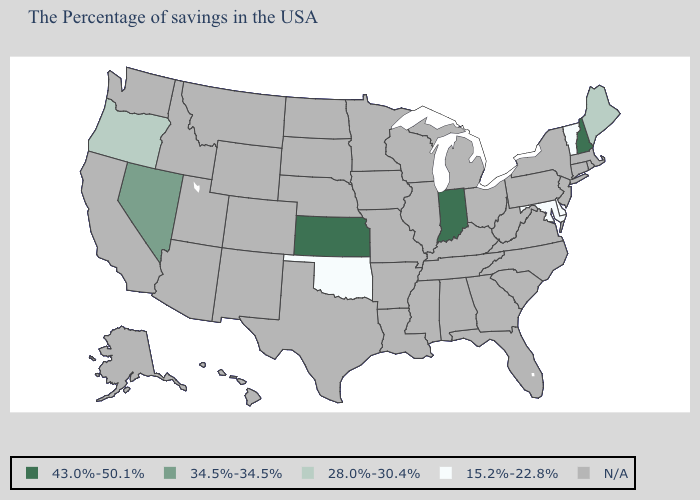Does the map have missing data?
Answer briefly. Yes. Name the states that have a value in the range 43.0%-50.1%?
Answer briefly. New Hampshire, Indiana, Kansas. What is the value of Vermont?
Quick response, please. 15.2%-22.8%. Among the states that border Idaho , does Nevada have the highest value?
Be succinct. Yes. Name the states that have a value in the range N/A?
Keep it brief. Massachusetts, Rhode Island, Connecticut, New York, New Jersey, Pennsylvania, Virginia, North Carolina, South Carolina, West Virginia, Ohio, Florida, Georgia, Michigan, Kentucky, Alabama, Tennessee, Wisconsin, Illinois, Mississippi, Louisiana, Missouri, Arkansas, Minnesota, Iowa, Nebraska, Texas, South Dakota, North Dakota, Wyoming, Colorado, New Mexico, Utah, Montana, Arizona, Idaho, California, Washington, Alaska, Hawaii. What is the value of Indiana?
Write a very short answer. 43.0%-50.1%. Which states have the lowest value in the West?
Be succinct. Oregon. What is the highest value in the West ?
Quick response, please. 34.5%-34.5%. What is the value of West Virginia?
Concise answer only. N/A. Name the states that have a value in the range N/A?
Be succinct. Massachusetts, Rhode Island, Connecticut, New York, New Jersey, Pennsylvania, Virginia, North Carolina, South Carolina, West Virginia, Ohio, Florida, Georgia, Michigan, Kentucky, Alabama, Tennessee, Wisconsin, Illinois, Mississippi, Louisiana, Missouri, Arkansas, Minnesota, Iowa, Nebraska, Texas, South Dakota, North Dakota, Wyoming, Colorado, New Mexico, Utah, Montana, Arizona, Idaho, California, Washington, Alaska, Hawaii. Name the states that have a value in the range 28.0%-30.4%?
Keep it brief. Maine, Oregon. Among the states that border Washington , which have the highest value?
Answer briefly. Oregon. What is the value of Alabama?
Quick response, please. N/A. What is the highest value in the South ?
Be succinct. 15.2%-22.8%. 